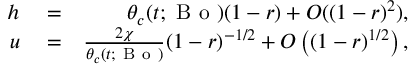<formula> <loc_0><loc_0><loc_500><loc_500>\begin{array} { r l r } { h } & = } & { \theta _ { c } ( t ; B o ) ( 1 - r ) + O ( ( 1 - r ) ^ { 2 } ) , } \\ { u } & = } & { \frac { 2 \chi } { \theta _ { c } ( t ; B o ) } ( 1 - r ) ^ { - 1 / 2 } + O \left ( ( 1 - r ) ^ { 1 / 2 } \right ) , } \end{array}</formula> 